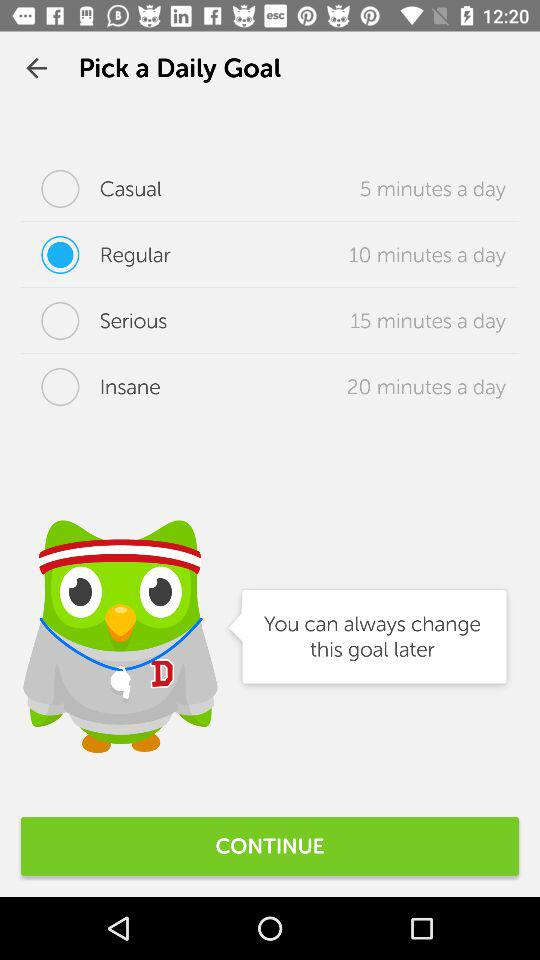How many minutes a day is the longest goal?
Answer the question using a single word or phrase. 20 minutes 